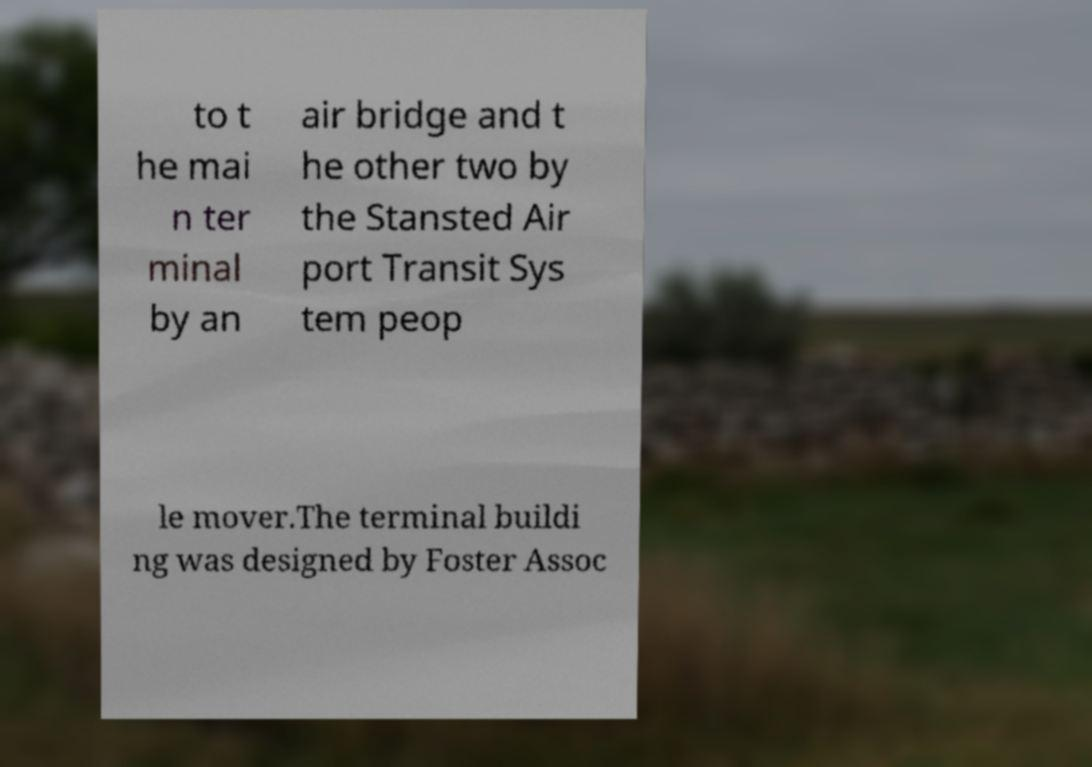Please read and relay the text visible in this image. What does it say? to t he mai n ter minal by an air bridge and t he other two by the Stansted Air port Transit Sys tem peop le mover.The terminal buildi ng was designed by Foster Assoc 